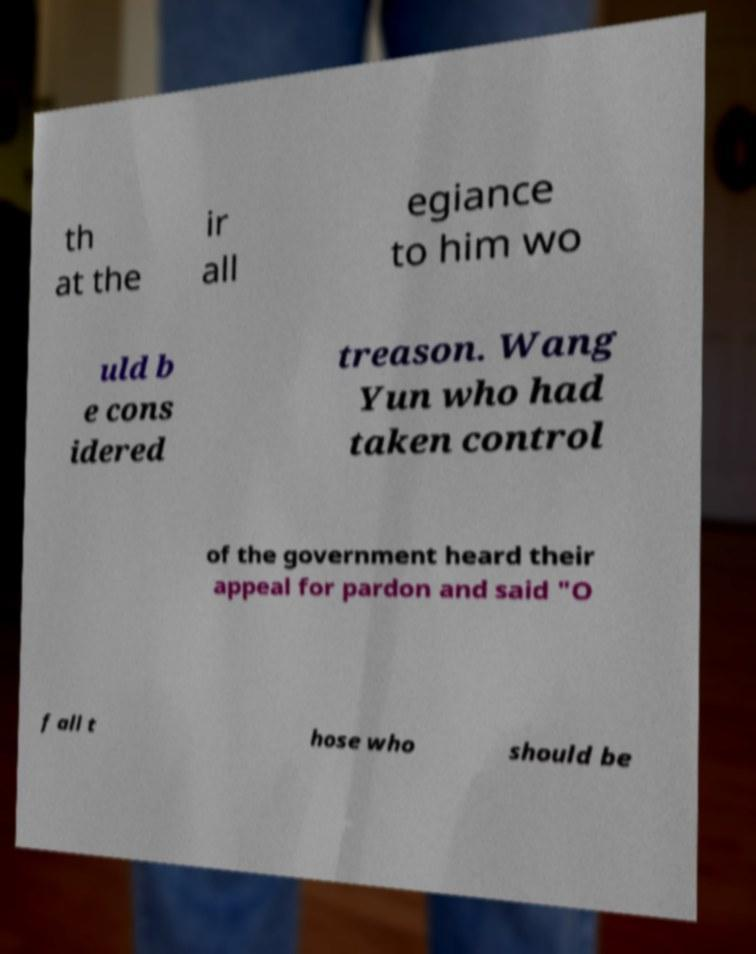For documentation purposes, I need the text within this image transcribed. Could you provide that? th at the ir all egiance to him wo uld b e cons idered treason. Wang Yun who had taken control of the government heard their appeal for pardon and said "O f all t hose who should be 